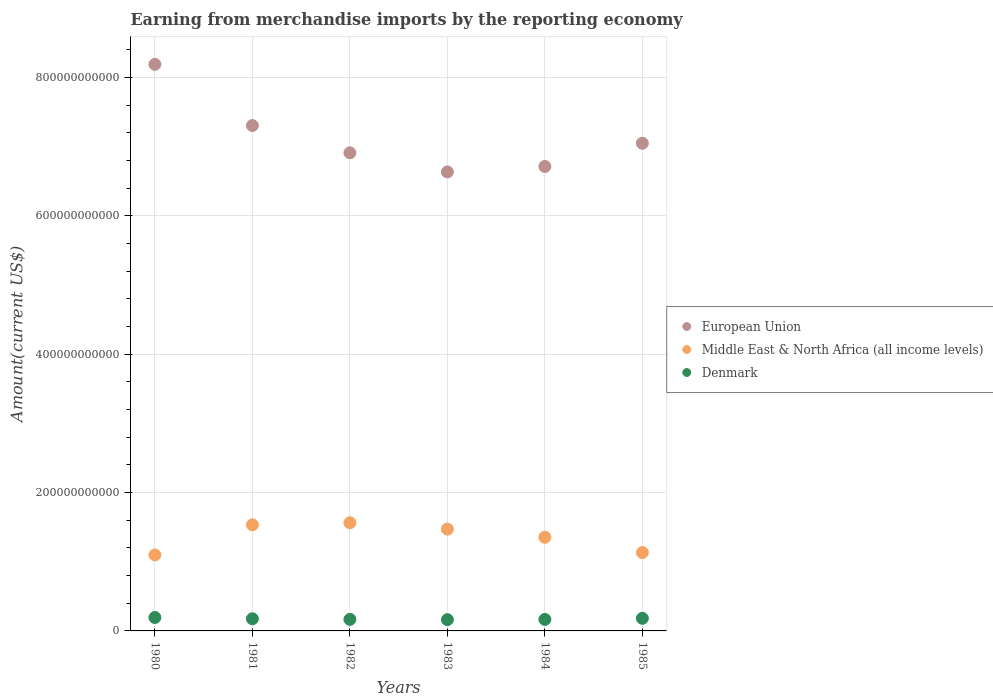How many different coloured dotlines are there?
Ensure brevity in your answer.  3. What is the amount earned from merchandise imports in Denmark in 1985?
Your answer should be very brief. 1.82e+1. Across all years, what is the maximum amount earned from merchandise imports in Middle East & North Africa (all income levels)?
Make the answer very short. 1.56e+11. Across all years, what is the minimum amount earned from merchandise imports in European Union?
Your answer should be very brief. 6.64e+11. In which year was the amount earned from merchandise imports in Denmark maximum?
Ensure brevity in your answer.  1980. What is the total amount earned from merchandise imports in European Union in the graph?
Offer a very short reply. 4.28e+12. What is the difference between the amount earned from merchandise imports in Middle East & North Africa (all income levels) in 1981 and that in 1983?
Your answer should be very brief. 6.28e+09. What is the difference between the amount earned from merchandise imports in European Union in 1980 and the amount earned from merchandise imports in Middle East & North Africa (all income levels) in 1982?
Give a very brief answer. 6.63e+11. What is the average amount earned from merchandise imports in Denmark per year?
Ensure brevity in your answer.  1.75e+1. In the year 1984, what is the difference between the amount earned from merchandise imports in Middle East & North Africa (all income levels) and amount earned from merchandise imports in Denmark?
Keep it short and to the point. 1.19e+11. In how many years, is the amount earned from merchandise imports in Denmark greater than 760000000000 US$?
Provide a short and direct response. 0. What is the ratio of the amount earned from merchandise imports in Denmark in 1983 to that in 1985?
Your answer should be very brief. 0.89. Is the amount earned from merchandise imports in Middle East & North Africa (all income levels) in 1982 less than that in 1984?
Make the answer very short. No. What is the difference between the highest and the second highest amount earned from merchandise imports in European Union?
Keep it short and to the point. 8.85e+1. What is the difference between the highest and the lowest amount earned from merchandise imports in Denmark?
Provide a succinct answer. 3.14e+09. In how many years, is the amount earned from merchandise imports in European Union greater than the average amount earned from merchandise imports in European Union taken over all years?
Offer a terse response. 2. Is the sum of the amount earned from merchandise imports in Denmark in 1980 and 1982 greater than the maximum amount earned from merchandise imports in European Union across all years?
Your answer should be very brief. No. Does the amount earned from merchandise imports in Denmark monotonically increase over the years?
Make the answer very short. No. Is the amount earned from merchandise imports in European Union strictly greater than the amount earned from merchandise imports in Middle East & North Africa (all income levels) over the years?
Your answer should be compact. Yes. How many dotlines are there?
Offer a terse response. 3. What is the difference between two consecutive major ticks on the Y-axis?
Your answer should be compact. 2.00e+11. What is the title of the graph?
Your answer should be compact. Earning from merchandise imports by the reporting economy. What is the label or title of the X-axis?
Your answer should be very brief. Years. What is the label or title of the Y-axis?
Give a very brief answer. Amount(current US$). What is the Amount(current US$) of European Union in 1980?
Your answer should be compact. 8.19e+11. What is the Amount(current US$) in Middle East & North Africa (all income levels) in 1980?
Ensure brevity in your answer.  1.10e+11. What is the Amount(current US$) of Denmark in 1980?
Your answer should be very brief. 1.94e+1. What is the Amount(current US$) in European Union in 1981?
Your answer should be very brief. 7.31e+11. What is the Amount(current US$) in Middle East & North Africa (all income levels) in 1981?
Your response must be concise. 1.53e+11. What is the Amount(current US$) in Denmark in 1981?
Your answer should be compact. 1.76e+1. What is the Amount(current US$) in European Union in 1982?
Offer a very short reply. 6.91e+11. What is the Amount(current US$) of Middle East & North Africa (all income levels) in 1982?
Keep it short and to the point. 1.56e+11. What is the Amount(current US$) in Denmark in 1982?
Offer a terse response. 1.67e+1. What is the Amount(current US$) in European Union in 1983?
Provide a short and direct response. 6.64e+11. What is the Amount(current US$) in Middle East & North Africa (all income levels) in 1983?
Offer a very short reply. 1.47e+11. What is the Amount(current US$) in Denmark in 1983?
Provide a short and direct response. 1.63e+1. What is the Amount(current US$) of European Union in 1984?
Your response must be concise. 6.71e+11. What is the Amount(current US$) in Middle East & North Africa (all income levels) in 1984?
Give a very brief answer. 1.35e+11. What is the Amount(current US$) in Denmark in 1984?
Your answer should be very brief. 1.66e+1. What is the Amount(current US$) of European Union in 1985?
Ensure brevity in your answer.  7.05e+11. What is the Amount(current US$) in Middle East & North Africa (all income levels) in 1985?
Provide a succinct answer. 1.13e+11. What is the Amount(current US$) of Denmark in 1985?
Provide a succinct answer. 1.82e+1. Across all years, what is the maximum Amount(current US$) of European Union?
Your response must be concise. 8.19e+11. Across all years, what is the maximum Amount(current US$) of Middle East & North Africa (all income levels)?
Your answer should be very brief. 1.56e+11. Across all years, what is the maximum Amount(current US$) of Denmark?
Offer a terse response. 1.94e+1. Across all years, what is the minimum Amount(current US$) of European Union?
Provide a short and direct response. 6.64e+11. Across all years, what is the minimum Amount(current US$) in Middle East & North Africa (all income levels)?
Keep it short and to the point. 1.10e+11. Across all years, what is the minimum Amount(current US$) in Denmark?
Your response must be concise. 1.63e+1. What is the total Amount(current US$) in European Union in the graph?
Keep it short and to the point. 4.28e+12. What is the total Amount(current US$) in Middle East & North Africa (all income levels) in the graph?
Your answer should be compact. 8.15e+11. What is the total Amount(current US$) in Denmark in the graph?
Your response must be concise. 1.05e+11. What is the difference between the Amount(current US$) of European Union in 1980 and that in 1981?
Ensure brevity in your answer.  8.85e+1. What is the difference between the Amount(current US$) in Middle East & North Africa (all income levels) in 1980 and that in 1981?
Offer a terse response. -4.35e+1. What is the difference between the Amount(current US$) in Denmark in 1980 and that in 1981?
Make the answer very short. 1.84e+09. What is the difference between the Amount(current US$) of European Union in 1980 and that in 1982?
Provide a short and direct response. 1.28e+11. What is the difference between the Amount(current US$) in Middle East & North Africa (all income levels) in 1980 and that in 1982?
Provide a succinct answer. -4.65e+1. What is the difference between the Amount(current US$) of Denmark in 1980 and that in 1982?
Ensure brevity in your answer.  2.72e+09. What is the difference between the Amount(current US$) of European Union in 1980 and that in 1983?
Ensure brevity in your answer.  1.55e+11. What is the difference between the Amount(current US$) of Middle East & North Africa (all income levels) in 1980 and that in 1983?
Your response must be concise. -3.73e+1. What is the difference between the Amount(current US$) in Denmark in 1980 and that in 1983?
Your answer should be very brief. 3.14e+09. What is the difference between the Amount(current US$) in European Union in 1980 and that in 1984?
Your answer should be compact. 1.48e+11. What is the difference between the Amount(current US$) of Middle East & North Africa (all income levels) in 1980 and that in 1984?
Provide a short and direct response. -2.56e+1. What is the difference between the Amount(current US$) in Denmark in 1980 and that in 1984?
Give a very brief answer. 2.80e+09. What is the difference between the Amount(current US$) of European Union in 1980 and that in 1985?
Offer a very short reply. 1.14e+11. What is the difference between the Amount(current US$) in Middle East & North Africa (all income levels) in 1980 and that in 1985?
Make the answer very short. -3.41e+09. What is the difference between the Amount(current US$) of Denmark in 1980 and that in 1985?
Provide a succinct answer. 1.19e+09. What is the difference between the Amount(current US$) of European Union in 1981 and that in 1982?
Offer a terse response. 3.94e+1. What is the difference between the Amount(current US$) in Middle East & North Africa (all income levels) in 1981 and that in 1982?
Your response must be concise. -2.96e+09. What is the difference between the Amount(current US$) in Denmark in 1981 and that in 1982?
Offer a very short reply. 8.74e+08. What is the difference between the Amount(current US$) in European Union in 1981 and that in 1983?
Offer a terse response. 6.70e+1. What is the difference between the Amount(current US$) of Middle East & North Africa (all income levels) in 1981 and that in 1983?
Your answer should be very brief. 6.28e+09. What is the difference between the Amount(current US$) in Denmark in 1981 and that in 1983?
Ensure brevity in your answer.  1.30e+09. What is the difference between the Amount(current US$) of European Union in 1981 and that in 1984?
Provide a short and direct response. 5.92e+1. What is the difference between the Amount(current US$) of Middle East & North Africa (all income levels) in 1981 and that in 1984?
Your answer should be compact. 1.80e+1. What is the difference between the Amount(current US$) in Denmark in 1981 and that in 1984?
Provide a succinct answer. 9.58e+08. What is the difference between the Amount(current US$) in European Union in 1981 and that in 1985?
Provide a succinct answer. 2.56e+1. What is the difference between the Amount(current US$) in Middle East & North Africa (all income levels) in 1981 and that in 1985?
Your answer should be very brief. 4.01e+1. What is the difference between the Amount(current US$) of Denmark in 1981 and that in 1985?
Your answer should be compact. -6.57e+08. What is the difference between the Amount(current US$) of European Union in 1982 and that in 1983?
Offer a very short reply. 2.76e+1. What is the difference between the Amount(current US$) of Middle East & North Africa (all income levels) in 1982 and that in 1983?
Offer a very short reply. 9.24e+09. What is the difference between the Amount(current US$) in Denmark in 1982 and that in 1983?
Give a very brief answer. 4.25e+08. What is the difference between the Amount(current US$) of European Union in 1982 and that in 1984?
Make the answer very short. 1.98e+1. What is the difference between the Amount(current US$) in Middle East & North Africa (all income levels) in 1982 and that in 1984?
Your answer should be compact. 2.10e+1. What is the difference between the Amount(current US$) of Denmark in 1982 and that in 1984?
Offer a terse response. 8.34e+07. What is the difference between the Amount(current US$) in European Union in 1982 and that in 1985?
Provide a succinct answer. -1.38e+1. What is the difference between the Amount(current US$) of Middle East & North Africa (all income levels) in 1982 and that in 1985?
Provide a succinct answer. 4.31e+1. What is the difference between the Amount(current US$) in Denmark in 1982 and that in 1985?
Offer a terse response. -1.53e+09. What is the difference between the Amount(current US$) of European Union in 1983 and that in 1984?
Ensure brevity in your answer.  -7.86e+09. What is the difference between the Amount(current US$) in Middle East & North Africa (all income levels) in 1983 and that in 1984?
Offer a very short reply. 1.17e+1. What is the difference between the Amount(current US$) in Denmark in 1983 and that in 1984?
Make the answer very short. -3.42e+08. What is the difference between the Amount(current US$) of European Union in 1983 and that in 1985?
Provide a short and direct response. -4.14e+1. What is the difference between the Amount(current US$) of Middle East & North Africa (all income levels) in 1983 and that in 1985?
Provide a short and direct response. 3.39e+1. What is the difference between the Amount(current US$) in Denmark in 1983 and that in 1985?
Provide a short and direct response. -1.96e+09. What is the difference between the Amount(current US$) of European Union in 1984 and that in 1985?
Provide a succinct answer. -3.36e+1. What is the difference between the Amount(current US$) in Middle East & North Africa (all income levels) in 1984 and that in 1985?
Ensure brevity in your answer.  2.21e+1. What is the difference between the Amount(current US$) of Denmark in 1984 and that in 1985?
Offer a terse response. -1.62e+09. What is the difference between the Amount(current US$) in European Union in 1980 and the Amount(current US$) in Middle East & North Africa (all income levels) in 1981?
Provide a short and direct response. 6.66e+11. What is the difference between the Amount(current US$) in European Union in 1980 and the Amount(current US$) in Denmark in 1981?
Provide a short and direct response. 8.01e+11. What is the difference between the Amount(current US$) in Middle East & North Africa (all income levels) in 1980 and the Amount(current US$) in Denmark in 1981?
Ensure brevity in your answer.  9.23e+1. What is the difference between the Amount(current US$) in European Union in 1980 and the Amount(current US$) in Middle East & North Africa (all income levels) in 1982?
Your answer should be very brief. 6.63e+11. What is the difference between the Amount(current US$) in European Union in 1980 and the Amount(current US$) in Denmark in 1982?
Your answer should be compact. 8.02e+11. What is the difference between the Amount(current US$) in Middle East & North Africa (all income levels) in 1980 and the Amount(current US$) in Denmark in 1982?
Offer a terse response. 9.32e+1. What is the difference between the Amount(current US$) of European Union in 1980 and the Amount(current US$) of Middle East & North Africa (all income levels) in 1983?
Give a very brief answer. 6.72e+11. What is the difference between the Amount(current US$) of European Union in 1980 and the Amount(current US$) of Denmark in 1983?
Make the answer very short. 8.03e+11. What is the difference between the Amount(current US$) of Middle East & North Africa (all income levels) in 1980 and the Amount(current US$) of Denmark in 1983?
Keep it short and to the point. 9.36e+1. What is the difference between the Amount(current US$) of European Union in 1980 and the Amount(current US$) of Middle East & North Africa (all income levels) in 1984?
Offer a terse response. 6.84e+11. What is the difference between the Amount(current US$) of European Union in 1980 and the Amount(current US$) of Denmark in 1984?
Keep it short and to the point. 8.02e+11. What is the difference between the Amount(current US$) in Middle East & North Africa (all income levels) in 1980 and the Amount(current US$) in Denmark in 1984?
Ensure brevity in your answer.  9.32e+1. What is the difference between the Amount(current US$) of European Union in 1980 and the Amount(current US$) of Middle East & North Africa (all income levels) in 1985?
Provide a succinct answer. 7.06e+11. What is the difference between the Amount(current US$) of European Union in 1980 and the Amount(current US$) of Denmark in 1985?
Provide a short and direct response. 8.01e+11. What is the difference between the Amount(current US$) in Middle East & North Africa (all income levels) in 1980 and the Amount(current US$) in Denmark in 1985?
Provide a short and direct response. 9.16e+1. What is the difference between the Amount(current US$) in European Union in 1981 and the Amount(current US$) in Middle East & North Africa (all income levels) in 1982?
Provide a succinct answer. 5.74e+11. What is the difference between the Amount(current US$) in European Union in 1981 and the Amount(current US$) in Denmark in 1982?
Give a very brief answer. 7.14e+11. What is the difference between the Amount(current US$) of Middle East & North Africa (all income levels) in 1981 and the Amount(current US$) of Denmark in 1982?
Your answer should be compact. 1.37e+11. What is the difference between the Amount(current US$) of European Union in 1981 and the Amount(current US$) of Middle East & North Africa (all income levels) in 1983?
Your answer should be very brief. 5.83e+11. What is the difference between the Amount(current US$) in European Union in 1981 and the Amount(current US$) in Denmark in 1983?
Keep it short and to the point. 7.14e+11. What is the difference between the Amount(current US$) in Middle East & North Africa (all income levels) in 1981 and the Amount(current US$) in Denmark in 1983?
Offer a very short reply. 1.37e+11. What is the difference between the Amount(current US$) of European Union in 1981 and the Amount(current US$) of Middle East & North Africa (all income levels) in 1984?
Your answer should be very brief. 5.95e+11. What is the difference between the Amount(current US$) of European Union in 1981 and the Amount(current US$) of Denmark in 1984?
Provide a succinct answer. 7.14e+11. What is the difference between the Amount(current US$) in Middle East & North Africa (all income levels) in 1981 and the Amount(current US$) in Denmark in 1984?
Provide a succinct answer. 1.37e+11. What is the difference between the Amount(current US$) of European Union in 1981 and the Amount(current US$) of Middle East & North Africa (all income levels) in 1985?
Your answer should be very brief. 6.17e+11. What is the difference between the Amount(current US$) in European Union in 1981 and the Amount(current US$) in Denmark in 1985?
Provide a short and direct response. 7.12e+11. What is the difference between the Amount(current US$) of Middle East & North Africa (all income levels) in 1981 and the Amount(current US$) of Denmark in 1985?
Your response must be concise. 1.35e+11. What is the difference between the Amount(current US$) in European Union in 1982 and the Amount(current US$) in Middle East & North Africa (all income levels) in 1983?
Offer a very short reply. 5.44e+11. What is the difference between the Amount(current US$) of European Union in 1982 and the Amount(current US$) of Denmark in 1983?
Provide a short and direct response. 6.75e+11. What is the difference between the Amount(current US$) in Middle East & North Africa (all income levels) in 1982 and the Amount(current US$) in Denmark in 1983?
Make the answer very short. 1.40e+11. What is the difference between the Amount(current US$) of European Union in 1982 and the Amount(current US$) of Middle East & North Africa (all income levels) in 1984?
Provide a succinct answer. 5.56e+11. What is the difference between the Amount(current US$) of European Union in 1982 and the Amount(current US$) of Denmark in 1984?
Your response must be concise. 6.75e+11. What is the difference between the Amount(current US$) of Middle East & North Africa (all income levels) in 1982 and the Amount(current US$) of Denmark in 1984?
Give a very brief answer. 1.40e+11. What is the difference between the Amount(current US$) of European Union in 1982 and the Amount(current US$) of Middle East & North Africa (all income levels) in 1985?
Give a very brief answer. 5.78e+11. What is the difference between the Amount(current US$) of European Union in 1982 and the Amount(current US$) of Denmark in 1985?
Offer a very short reply. 6.73e+11. What is the difference between the Amount(current US$) of Middle East & North Africa (all income levels) in 1982 and the Amount(current US$) of Denmark in 1985?
Offer a very short reply. 1.38e+11. What is the difference between the Amount(current US$) of European Union in 1983 and the Amount(current US$) of Middle East & North Africa (all income levels) in 1984?
Your answer should be compact. 5.28e+11. What is the difference between the Amount(current US$) in European Union in 1983 and the Amount(current US$) in Denmark in 1984?
Provide a succinct answer. 6.47e+11. What is the difference between the Amount(current US$) of Middle East & North Africa (all income levels) in 1983 and the Amount(current US$) of Denmark in 1984?
Your answer should be compact. 1.31e+11. What is the difference between the Amount(current US$) of European Union in 1983 and the Amount(current US$) of Middle East & North Africa (all income levels) in 1985?
Keep it short and to the point. 5.50e+11. What is the difference between the Amount(current US$) in European Union in 1983 and the Amount(current US$) in Denmark in 1985?
Your answer should be very brief. 6.45e+11. What is the difference between the Amount(current US$) in Middle East & North Africa (all income levels) in 1983 and the Amount(current US$) in Denmark in 1985?
Offer a terse response. 1.29e+11. What is the difference between the Amount(current US$) of European Union in 1984 and the Amount(current US$) of Middle East & North Africa (all income levels) in 1985?
Your answer should be compact. 5.58e+11. What is the difference between the Amount(current US$) of European Union in 1984 and the Amount(current US$) of Denmark in 1985?
Your response must be concise. 6.53e+11. What is the difference between the Amount(current US$) of Middle East & North Africa (all income levels) in 1984 and the Amount(current US$) of Denmark in 1985?
Make the answer very short. 1.17e+11. What is the average Amount(current US$) in European Union per year?
Your response must be concise. 7.13e+11. What is the average Amount(current US$) in Middle East & North Africa (all income levels) per year?
Your answer should be very brief. 1.36e+11. What is the average Amount(current US$) of Denmark per year?
Your response must be concise. 1.75e+1. In the year 1980, what is the difference between the Amount(current US$) in European Union and Amount(current US$) in Middle East & North Africa (all income levels)?
Provide a short and direct response. 7.09e+11. In the year 1980, what is the difference between the Amount(current US$) in European Union and Amount(current US$) in Denmark?
Offer a terse response. 8.00e+11. In the year 1980, what is the difference between the Amount(current US$) in Middle East & North Africa (all income levels) and Amount(current US$) in Denmark?
Your answer should be compact. 9.04e+1. In the year 1981, what is the difference between the Amount(current US$) of European Union and Amount(current US$) of Middle East & North Africa (all income levels)?
Offer a terse response. 5.77e+11. In the year 1981, what is the difference between the Amount(current US$) of European Union and Amount(current US$) of Denmark?
Give a very brief answer. 7.13e+11. In the year 1981, what is the difference between the Amount(current US$) in Middle East & North Africa (all income levels) and Amount(current US$) in Denmark?
Offer a very short reply. 1.36e+11. In the year 1982, what is the difference between the Amount(current US$) of European Union and Amount(current US$) of Middle East & North Africa (all income levels)?
Keep it short and to the point. 5.35e+11. In the year 1982, what is the difference between the Amount(current US$) of European Union and Amount(current US$) of Denmark?
Offer a very short reply. 6.74e+11. In the year 1982, what is the difference between the Amount(current US$) in Middle East & North Africa (all income levels) and Amount(current US$) in Denmark?
Offer a very short reply. 1.40e+11. In the year 1983, what is the difference between the Amount(current US$) in European Union and Amount(current US$) in Middle East & North Africa (all income levels)?
Provide a succinct answer. 5.16e+11. In the year 1983, what is the difference between the Amount(current US$) of European Union and Amount(current US$) of Denmark?
Make the answer very short. 6.47e+11. In the year 1983, what is the difference between the Amount(current US$) of Middle East & North Africa (all income levels) and Amount(current US$) of Denmark?
Your answer should be very brief. 1.31e+11. In the year 1984, what is the difference between the Amount(current US$) in European Union and Amount(current US$) in Middle East & North Africa (all income levels)?
Your answer should be compact. 5.36e+11. In the year 1984, what is the difference between the Amount(current US$) of European Union and Amount(current US$) of Denmark?
Keep it short and to the point. 6.55e+11. In the year 1984, what is the difference between the Amount(current US$) in Middle East & North Africa (all income levels) and Amount(current US$) in Denmark?
Your answer should be very brief. 1.19e+11. In the year 1985, what is the difference between the Amount(current US$) in European Union and Amount(current US$) in Middle East & North Africa (all income levels)?
Make the answer very short. 5.92e+11. In the year 1985, what is the difference between the Amount(current US$) of European Union and Amount(current US$) of Denmark?
Keep it short and to the point. 6.87e+11. In the year 1985, what is the difference between the Amount(current US$) in Middle East & North Africa (all income levels) and Amount(current US$) in Denmark?
Your response must be concise. 9.50e+1. What is the ratio of the Amount(current US$) in European Union in 1980 to that in 1981?
Your response must be concise. 1.12. What is the ratio of the Amount(current US$) of Middle East & North Africa (all income levels) in 1980 to that in 1981?
Keep it short and to the point. 0.72. What is the ratio of the Amount(current US$) in Denmark in 1980 to that in 1981?
Ensure brevity in your answer.  1.1. What is the ratio of the Amount(current US$) of European Union in 1980 to that in 1982?
Make the answer very short. 1.19. What is the ratio of the Amount(current US$) of Middle East & North Africa (all income levels) in 1980 to that in 1982?
Ensure brevity in your answer.  0.7. What is the ratio of the Amount(current US$) of Denmark in 1980 to that in 1982?
Provide a short and direct response. 1.16. What is the ratio of the Amount(current US$) of European Union in 1980 to that in 1983?
Your answer should be compact. 1.23. What is the ratio of the Amount(current US$) of Middle East & North Africa (all income levels) in 1980 to that in 1983?
Your response must be concise. 0.75. What is the ratio of the Amount(current US$) in Denmark in 1980 to that in 1983?
Keep it short and to the point. 1.19. What is the ratio of the Amount(current US$) of European Union in 1980 to that in 1984?
Offer a very short reply. 1.22. What is the ratio of the Amount(current US$) in Middle East & North Africa (all income levels) in 1980 to that in 1984?
Ensure brevity in your answer.  0.81. What is the ratio of the Amount(current US$) of Denmark in 1980 to that in 1984?
Your answer should be very brief. 1.17. What is the ratio of the Amount(current US$) in European Union in 1980 to that in 1985?
Offer a very short reply. 1.16. What is the ratio of the Amount(current US$) in Middle East & North Africa (all income levels) in 1980 to that in 1985?
Ensure brevity in your answer.  0.97. What is the ratio of the Amount(current US$) of Denmark in 1980 to that in 1985?
Your answer should be compact. 1.07. What is the ratio of the Amount(current US$) in European Union in 1981 to that in 1982?
Ensure brevity in your answer.  1.06. What is the ratio of the Amount(current US$) in Middle East & North Africa (all income levels) in 1981 to that in 1982?
Provide a short and direct response. 0.98. What is the ratio of the Amount(current US$) in Denmark in 1981 to that in 1982?
Your answer should be compact. 1.05. What is the ratio of the Amount(current US$) of European Union in 1981 to that in 1983?
Make the answer very short. 1.1. What is the ratio of the Amount(current US$) in Middle East & North Africa (all income levels) in 1981 to that in 1983?
Provide a succinct answer. 1.04. What is the ratio of the Amount(current US$) in Denmark in 1981 to that in 1983?
Make the answer very short. 1.08. What is the ratio of the Amount(current US$) in European Union in 1981 to that in 1984?
Ensure brevity in your answer.  1.09. What is the ratio of the Amount(current US$) of Middle East & North Africa (all income levels) in 1981 to that in 1984?
Offer a very short reply. 1.13. What is the ratio of the Amount(current US$) of Denmark in 1981 to that in 1984?
Give a very brief answer. 1.06. What is the ratio of the Amount(current US$) of European Union in 1981 to that in 1985?
Provide a succinct answer. 1.04. What is the ratio of the Amount(current US$) of Middle East & North Africa (all income levels) in 1981 to that in 1985?
Offer a very short reply. 1.35. What is the ratio of the Amount(current US$) in Denmark in 1981 to that in 1985?
Provide a short and direct response. 0.96. What is the ratio of the Amount(current US$) in European Union in 1982 to that in 1983?
Your answer should be very brief. 1.04. What is the ratio of the Amount(current US$) in Middle East & North Africa (all income levels) in 1982 to that in 1983?
Offer a terse response. 1.06. What is the ratio of the Amount(current US$) of Denmark in 1982 to that in 1983?
Ensure brevity in your answer.  1.03. What is the ratio of the Amount(current US$) of European Union in 1982 to that in 1984?
Offer a terse response. 1.03. What is the ratio of the Amount(current US$) of Middle East & North Africa (all income levels) in 1982 to that in 1984?
Your response must be concise. 1.15. What is the ratio of the Amount(current US$) in Denmark in 1982 to that in 1984?
Give a very brief answer. 1. What is the ratio of the Amount(current US$) in European Union in 1982 to that in 1985?
Ensure brevity in your answer.  0.98. What is the ratio of the Amount(current US$) of Middle East & North Africa (all income levels) in 1982 to that in 1985?
Your answer should be compact. 1.38. What is the ratio of the Amount(current US$) of Denmark in 1982 to that in 1985?
Your response must be concise. 0.92. What is the ratio of the Amount(current US$) in European Union in 1983 to that in 1984?
Provide a short and direct response. 0.99. What is the ratio of the Amount(current US$) of Middle East & North Africa (all income levels) in 1983 to that in 1984?
Give a very brief answer. 1.09. What is the ratio of the Amount(current US$) of Denmark in 1983 to that in 1984?
Provide a short and direct response. 0.98. What is the ratio of the Amount(current US$) of Middle East & North Africa (all income levels) in 1983 to that in 1985?
Your answer should be compact. 1.3. What is the ratio of the Amount(current US$) of Denmark in 1983 to that in 1985?
Offer a very short reply. 0.89. What is the ratio of the Amount(current US$) of European Union in 1984 to that in 1985?
Offer a very short reply. 0.95. What is the ratio of the Amount(current US$) of Middle East & North Africa (all income levels) in 1984 to that in 1985?
Provide a succinct answer. 1.2. What is the ratio of the Amount(current US$) of Denmark in 1984 to that in 1985?
Your answer should be compact. 0.91. What is the difference between the highest and the second highest Amount(current US$) in European Union?
Give a very brief answer. 8.85e+1. What is the difference between the highest and the second highest Amount(current US$) of Middle East & North Africa (all income levels)?
Your answer should be compact. 2.96e+09. What is the difference between the highest and the second highest Amount(current US$) in Denmark?
Your answer should be compact. 1.19e+09. What is the difference between the highest and the lowest Amount(current US$) in European Union?
Make the answer very short. 1.55e+11. What is the difference between the highest and the lowest Amount(current US$) in Middle East & North Africa (all income levels)?
Make the answer very short. 4.65e+1. What is the difference between the highest and the lowest Amount(current US$) in Denmark?
Your answer should be very brief. 3.14e+09. 